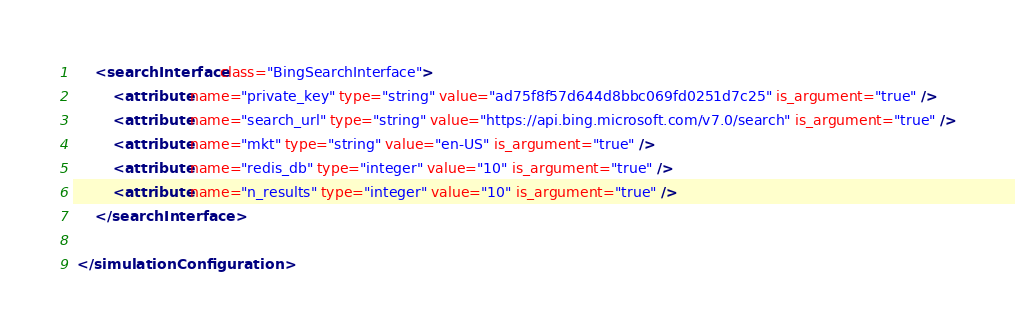Convert code to text. <code><loc_0><loc_0><loc_500><loc_500><_XML_>
     <searchInterface class="BingSearchInterface">
         <attribute name="private_key" type="string" value="ad75f8f57d644d8bbc069fd0251d7c25" is_argument="true" />
         <attribute name="search_url" type="string" value="https://api.bing.microsoft.com/v7.0/search" is_argument="true" />
         <attribute name="mkt" type="string" value="en-US" is_argument="true" />
         <attribute name="redis_db" type="integer" value="10" is_argument="true" />
         <attribute name="n_results" type="integer" value="10" is_argument="true" />
     </searchInterface>

 </simulationConfiguration></code> 